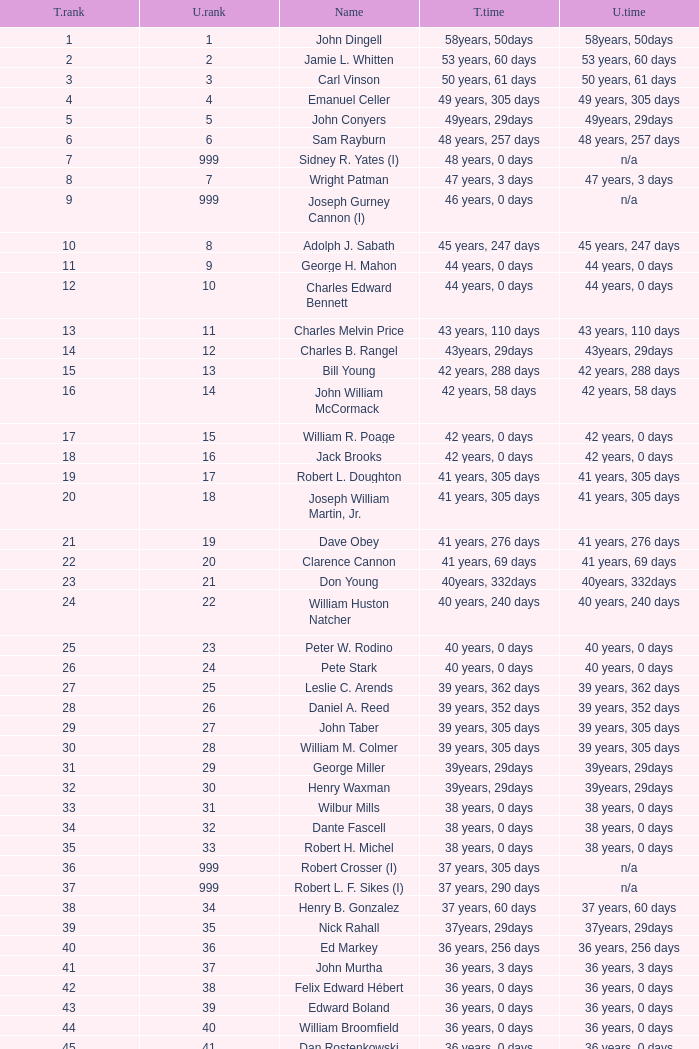Who has a total tenure time and uninterrupted time of 36 years, 0 days, as well as a total tenure rank of 49? James Oberstar. 